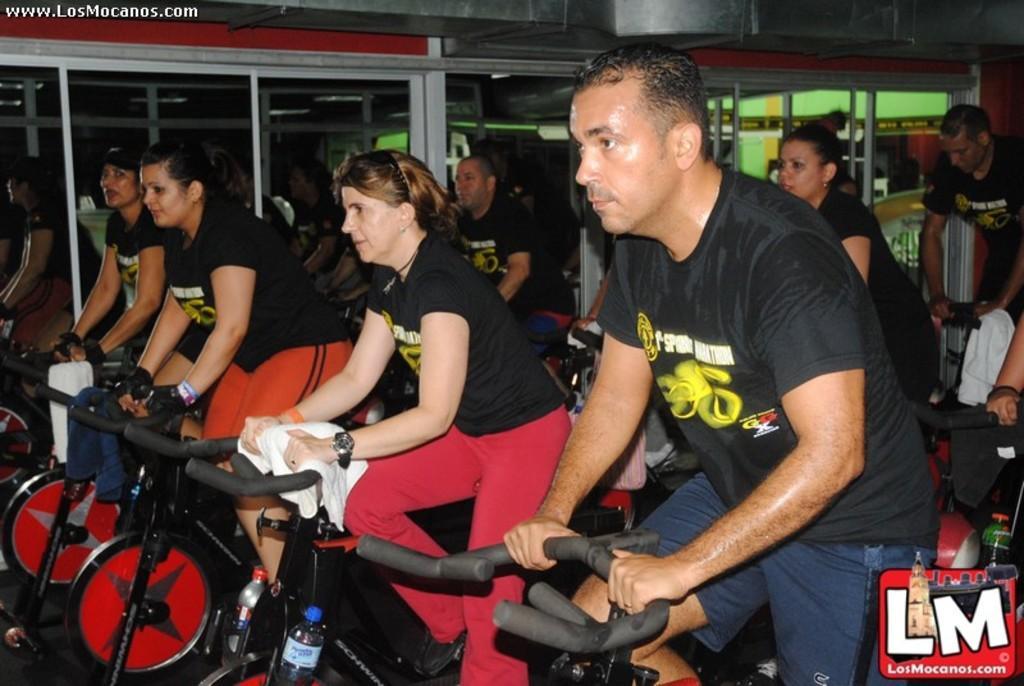Please provide a concise description of this image. In this image I can see few people are riding bicycles. I can see few bottles and they are wearing different color dresses. Back I can see few glass doors. 